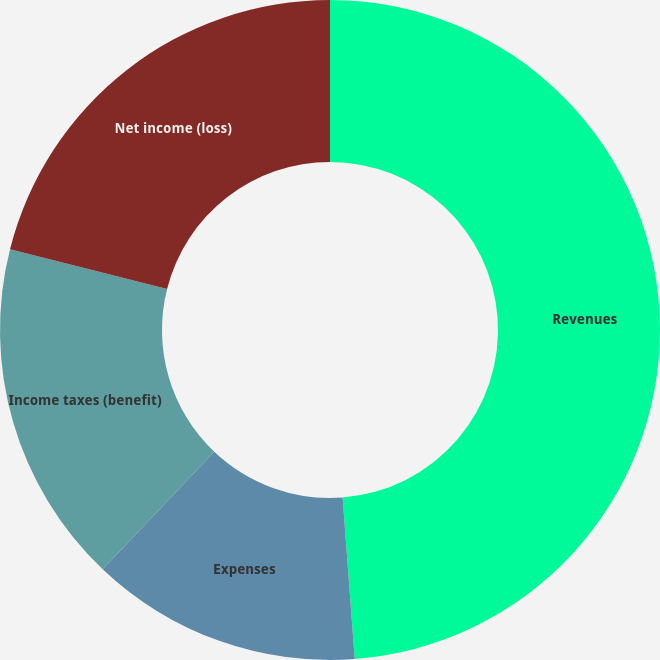<chart> <loc_0><loc_0><loc_500><loc_500><pie_chart><fcel>Revenues<fcel>Expenses<fcel>Income taxes (benefit)<fcel>Net income (loss)<nl><fcel>48.81%<fcel>13.29%<fcel>16.84%<fcel>21.07%<nl></chart> 